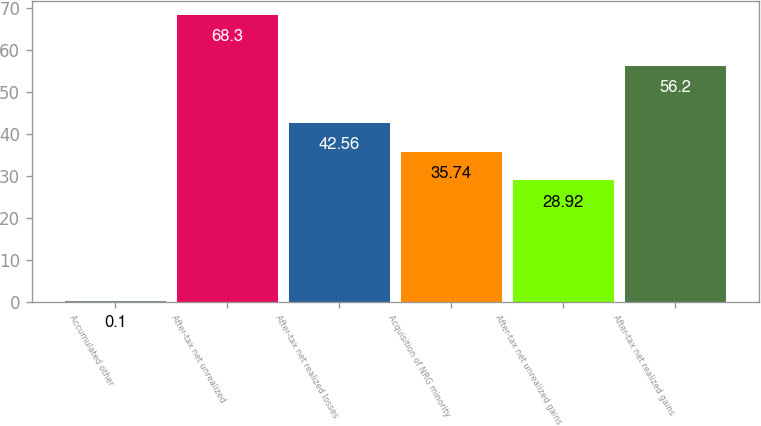Convert chart. <chart><loc_0><loc_0><loc_500><loc_500><bar_chart><fcel>Accumulated other<fcel>After-tax net unrealized<fcel>After-tax net realized losses<fcel>Acquisition of NRG minority<fcel>After-tax net unrealized gains<fcel>After-tax net realized gains<nl><fcel>0.1<fcel>68.3<fcel>42.56<fcel>35.74<fcel>28.92<fcel>56.2<nl></chart> 